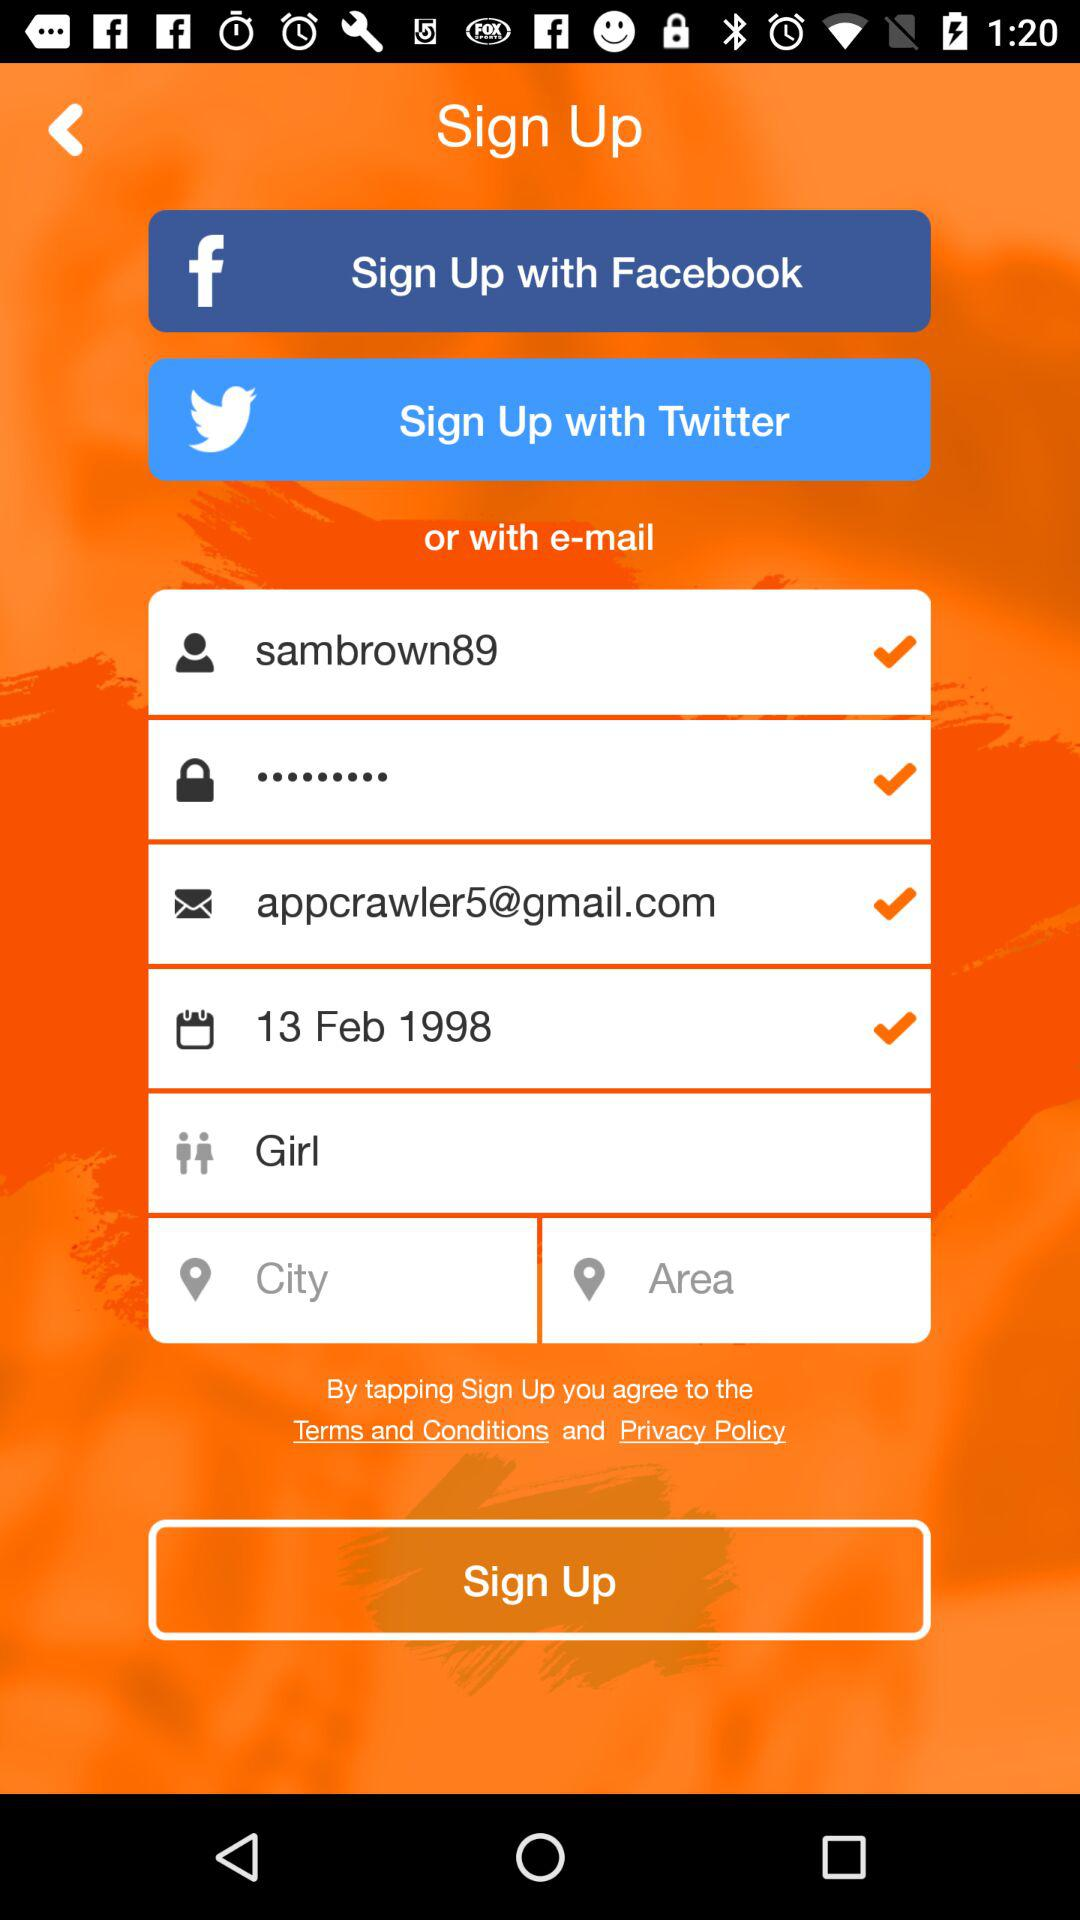What is the date of birth? The date of birth is February 13, 1998. 